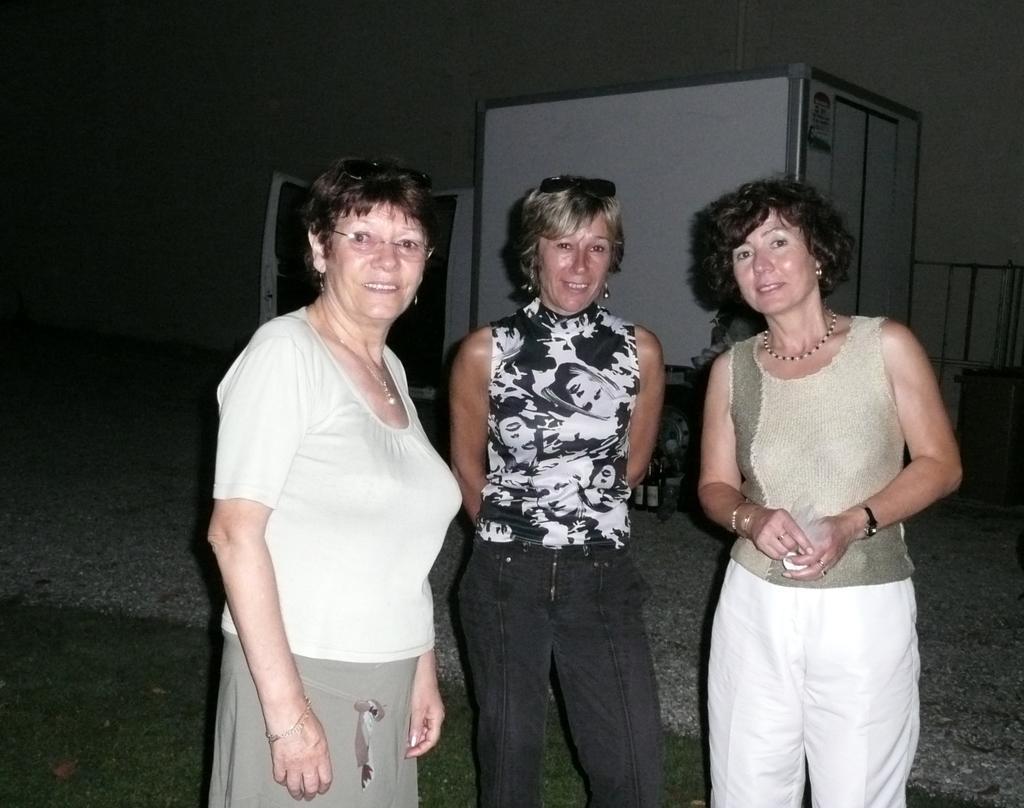Can you describe this image briefly? In this image we can see three ladies standing and smiling. In the background there is a vehicle and a wall. At the bottom there is a road. 